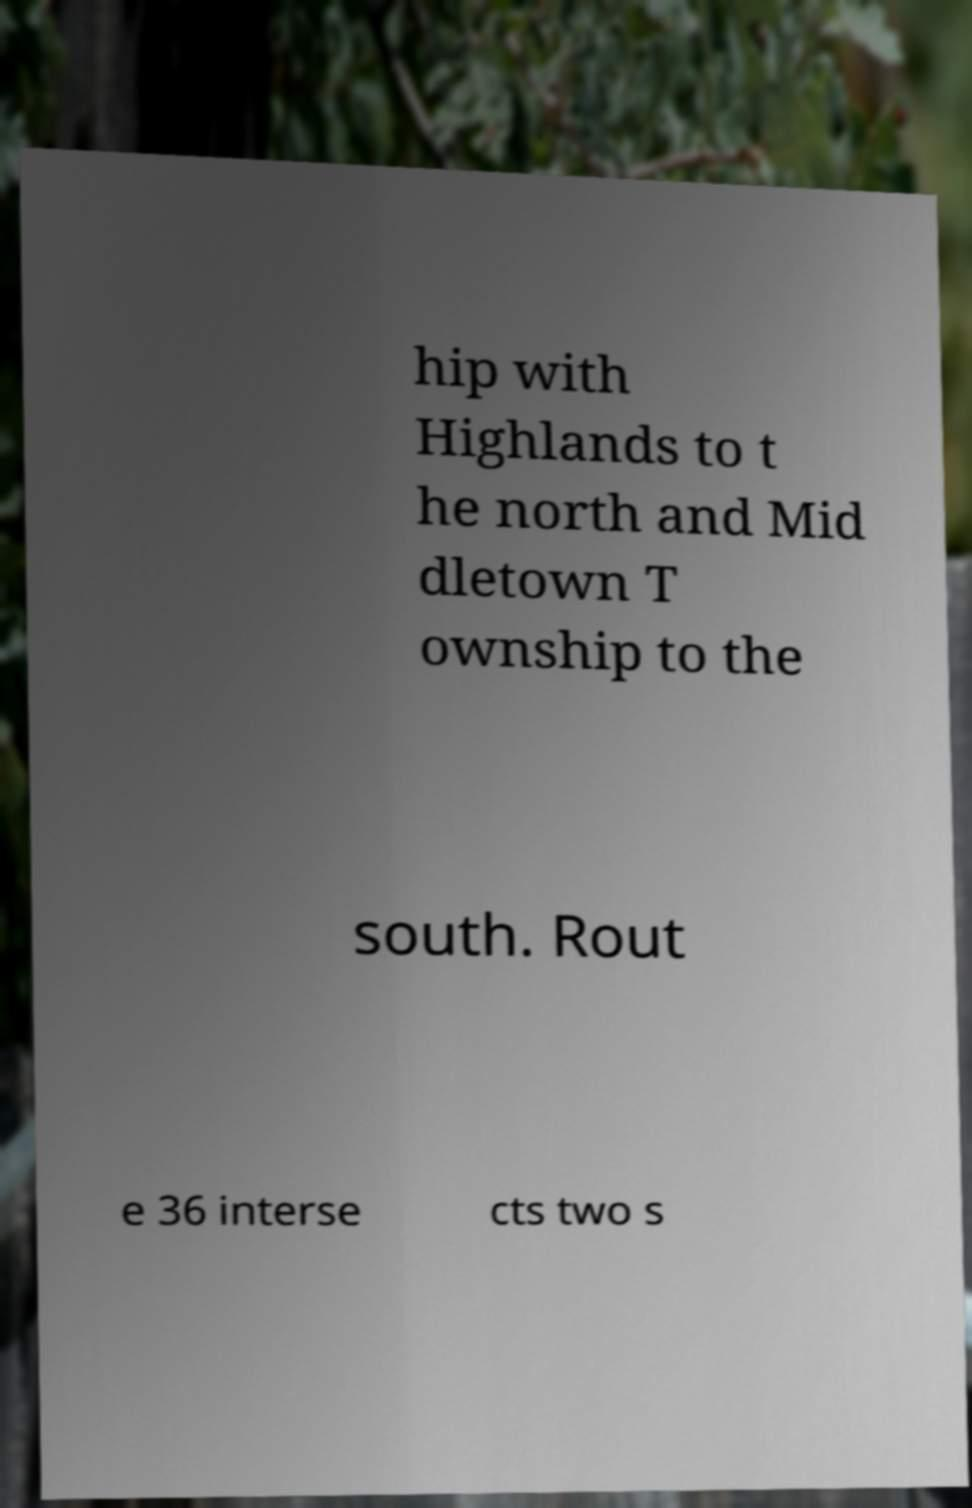Could you assist in decoding the text presented in this image and type it out clearly? hip with Highlands to t he north and Mid dletown T ownship to the south. Rout e 36 interse cts two s 